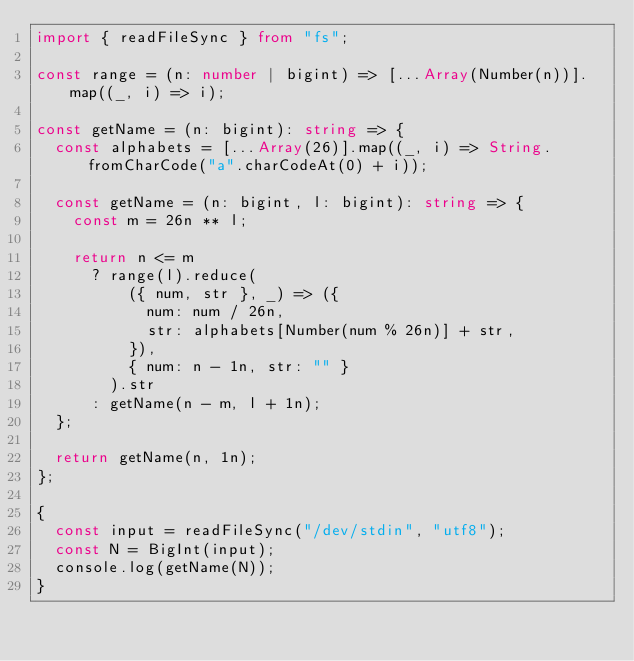<code> <loc_0><loc_0><loc_500><loc_500><_TypeScript_>import { readFileSync } from "fs";

const range = (n: number | bigint) => [...Array(Number(n))].map((_, i) => i);

const getName = (n: bigint): string => {
  const alphabets = [...Array(26)].map((_, i) => String.fromCharCode("a".charCodeAt(0) + i));

  const getName = (n: bigint, l: bigint): string => {
    const m = 26n ** l;

    return n <= m
      ? range(l).reduce(
          ({ num, str }, _) => ({
            num: num / 26n,
            str: alphabets[Number(num % 26n)] + str,
          }),
          { num: n - 1n, str: "" }
        ).str
      : getName(n - m, l + 1n);
  };

  return getName(n, 1n);
};

{
  const input = readFileSync("/dev/stdin", "utf8");
  const N = BigInt(input);
  console.log(getName(N));
}
</code> 